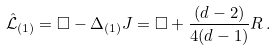<formula> <loc_0><loc_0><loc_500><loc_500>\hat { \mathcal { L } } _ { ( 1 ) } = \Box - \Delta _ { ( 1 ) } J = \Box + \frac { ( d - 2 ) } { 4 ( d - 1 ) } R \, .</formula> 